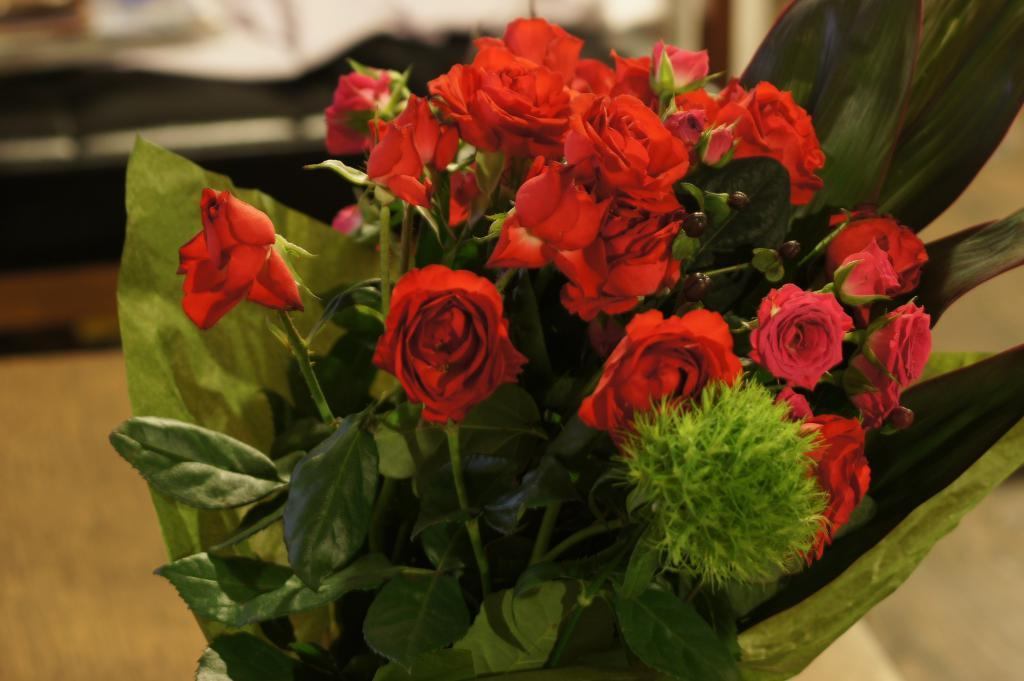What type of flowers are in the image? There are red color roses in the image. What other elements can be seen in the image besides the flowers? There are green leaves in the image. How would you describe the background of the image? The background of the image is blurred. Can you tell me how many giraffes are visible in the image? There are no giraffes present in the image. What type of nerve is responsible for the color of the roses in the image? The image does not provide information about the nerves responsible for the color of the roses. 